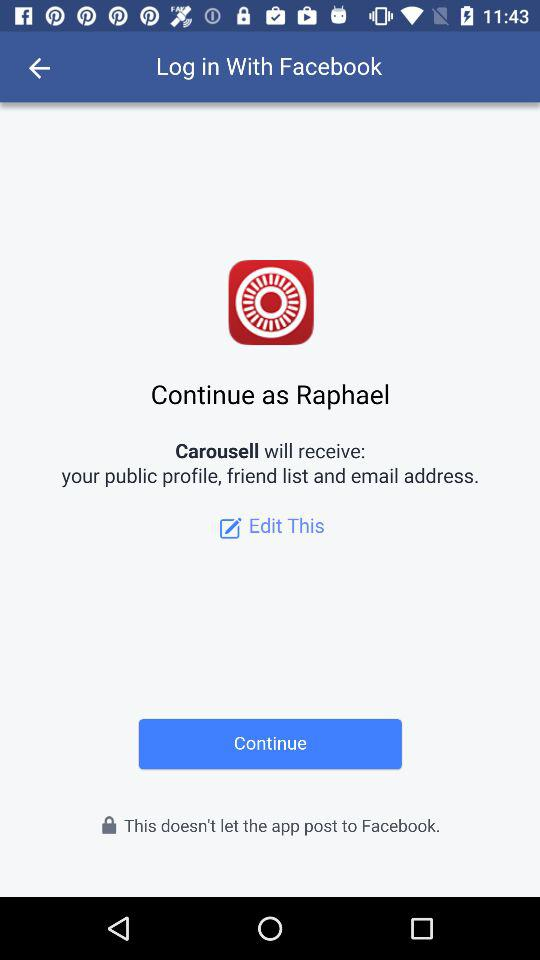How can we log in? You can log in through "Facebook". 